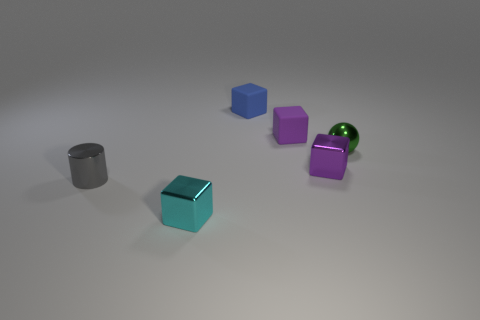What number of small cyan shiny cubes are there?
Give a very brief answer. 1. There is a matte thing that is on the right side of the object behind the purple rubber block; what color is it?
Make the answer very short. Purple. What is the color of the cylinder that is the same size as the green metallic object?
Provide a short and direct response. Gray. Is there a large shiny cube of the same color as the metal sphere?
Offer a terse response. No. Are any tiny green cylinders visible?
Your answer should be very brief. No. There is a metal thing in front of the cylinder; what shape is it?
Ensure brevity in your answer.  Cube. How many shiny objects are both in front of the small sphere and behind the small gray shiny cylinder?
Your answer should be compact. 1. What number of other things are there of the same size as the purple rubber cube?
Make the answer very short. 5. Do the tiny thing that is in front of the gray thing and the small purple thing in front of the tiny green ball have the same shape?
Make the answer very short. Yes. How many objects are either purple shiny things or metal objects on the right side of the gray metal thing?
Make the answer very short. 3. 